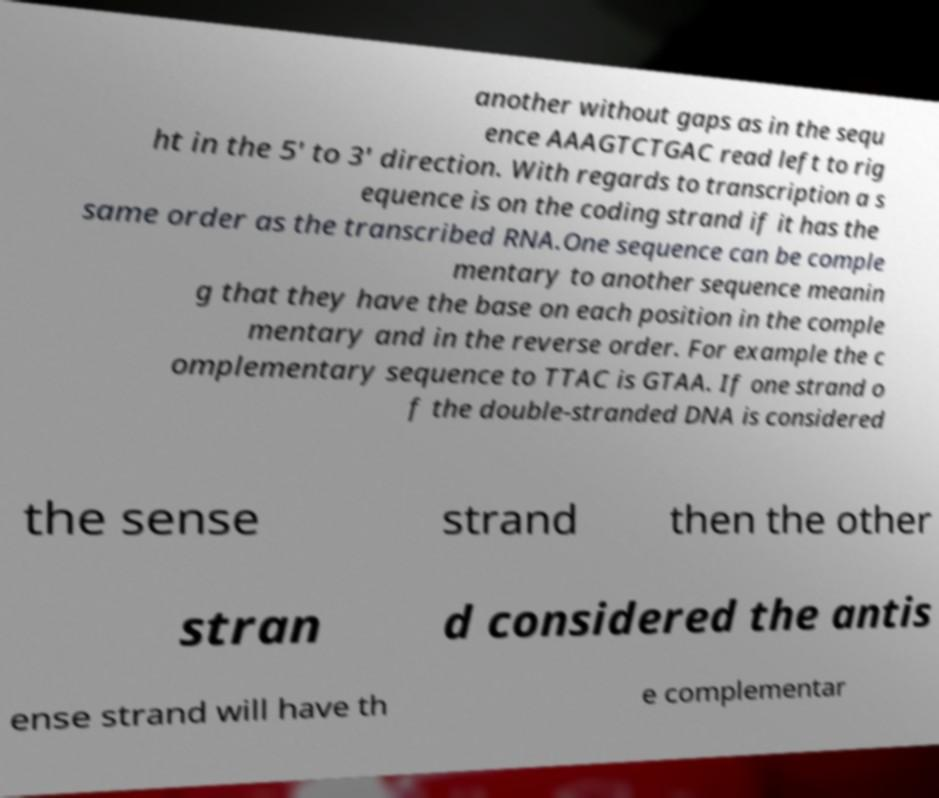Could you extract and type out the text from this image? another without gaps as in the sequ ence AAAGTCTGAC read left to rig ht in the 5' to 3' direction. With regards to transcription a s equence is on the coding strand if it has the same order as the transcribed RNA.One sequence can be comple mentary to another sequence meanin g that they have the base on each position in the comple mentary and in the reverse order. For example the c omplementary sequence to TTAC is GTAA. If one strand o f the double-stranded DNA is considered the sense strand then the other stran d considered the antis ense strand will have th e complementar 